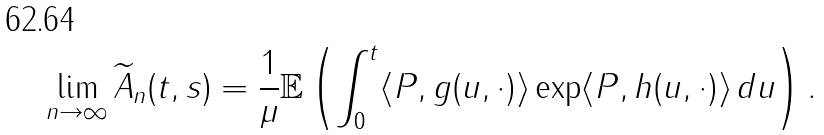Convert formula to latex. <formula><loc_0><loc_0><loc_500><loc_500>\lim _ { n \to \infty } \widetilde { A } _ { n } ( t , s ) = \frac { 1 } { \mu } \mathbb { E } \left ( \int _ { 0 } ^ { t } \langle P , g ( u , \cdot ) \rangle \exp \langle P , h ( u , \cdot ) \rangle \, d u \right ) .</formula> 